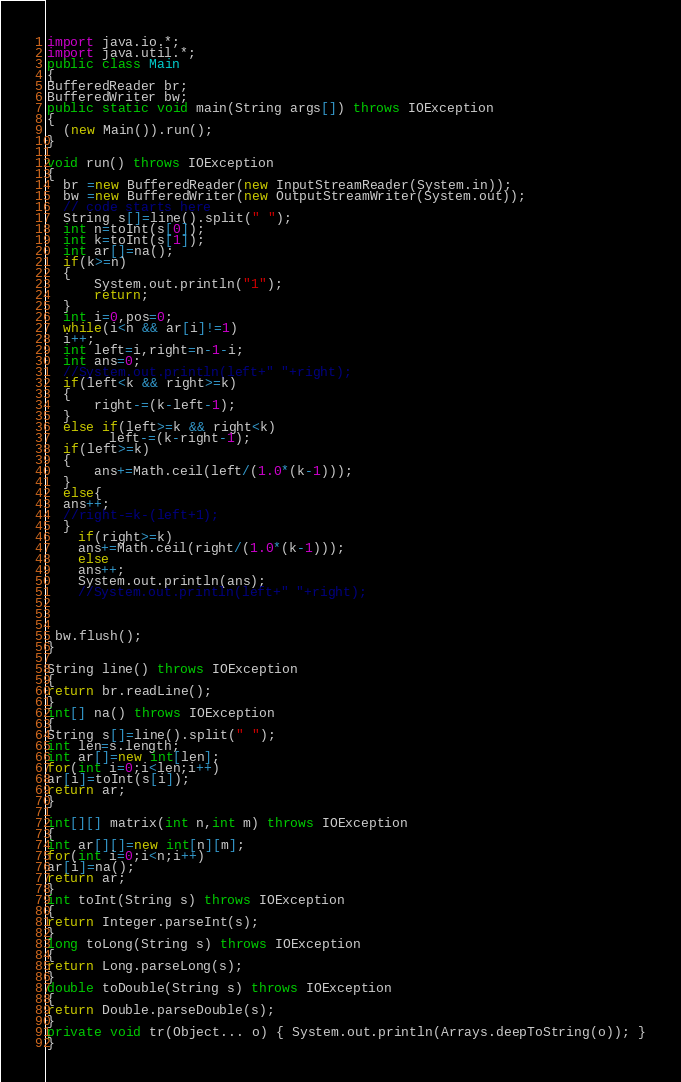Convert code to text. <code><loc_0><loc_0><loc_500><loc_500><_Java_>import java.io.*;
import java.util.*;
public class Main
{
BufferedReader br;
BufferedWriter bw;
public static void main(String args[]) throws IOException
{
  (new Main()).run();
}

void run() throws IOException
{
  br =new BufferedReader(new InputStreamReader(System.in));
  bw =new BufferedWriter(new OutputStreamWriter(System.out));
  // code starts here
  String s[]=line().split(" ");
  int n=toInt(s[0]);
  int k=toInt(s[1]);
  int ar[]=na();
  if(k>=n)
  {
      System.out.println("1");
      return;
  }
  int i=0,pos=0;
  while(i<n && ar[i]!=1)
  i++;
  int left=i,right=n-1-i;
  int ans=0;
  //System.out.println(left+" "+right);
  if(left<k && right>=k)
  {
      right-=(k-left-1);
  }
  else if(left>=k && right<k)
        left-=(k-right-1);
  if(left>=k)
  {
      ans+=Math.ceil(left/(1.0*(k-1)));
  }
  else{
  ans++;
  //right-=k-(left+1);
  }
    if(right>=k)
    ans+=Math.ceil(right/(1.0*(k-1)));
    else 
    ans++;
    System.out.println(ans);
    //System.out.println(left+" "+right);
    


 bw.flush();
}

String line() throws IOException
{
return br.readLine();
}
int[] na() throws IOException
{
String s[]=line().split(" ");
int len=s.length;
int ar[]=new int[len];
for(int i=0;i<len;i++)
ar[i]=toInt(s[i]);
return ar;
}

int[][] matrix(int n,int m) throws IOException
{
int ar[][]=new int[n][m];
for(int i=0;i<n;i++)
ar[i]=na();
return ar;
}
int toInt(String s) throws IOException
{
return Integer.parseInt(s);
} 
long toLong(String s) throws IOException
{
return Long.parseLong(s);
}
double toDouble(String s) throws IOException
{
return Double.parseDouble(s);
}
private void tr(Object... o) { System.out.println(Arrays.deepToString(o)); }
}</code> 